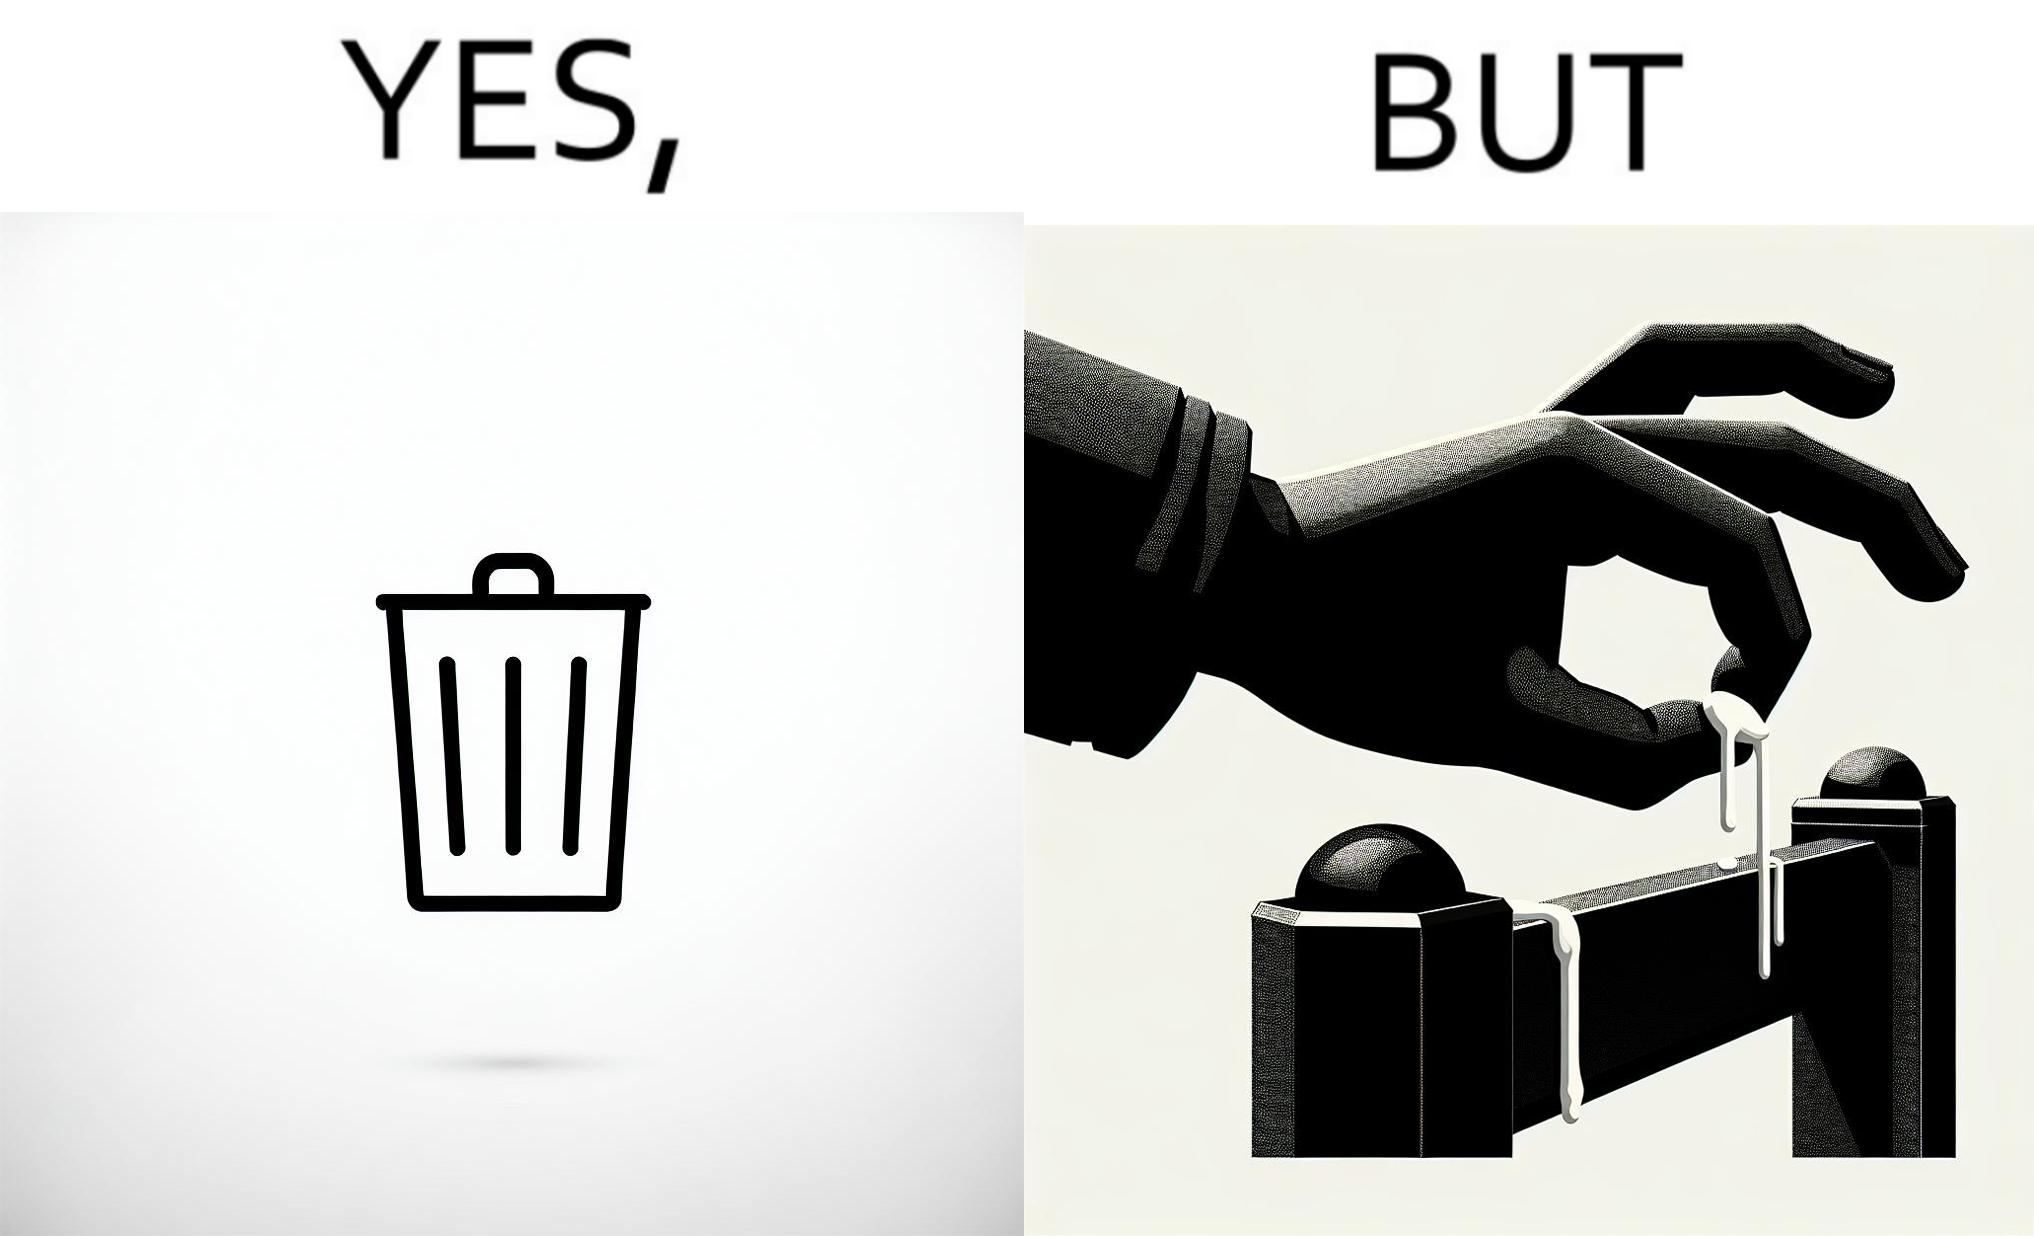What is shown in this image? The images are ironic because even though garbage bins are provided for humans to dispose waste, by habit humans still choose to make surroundings dirty by disposing garbage improperly 